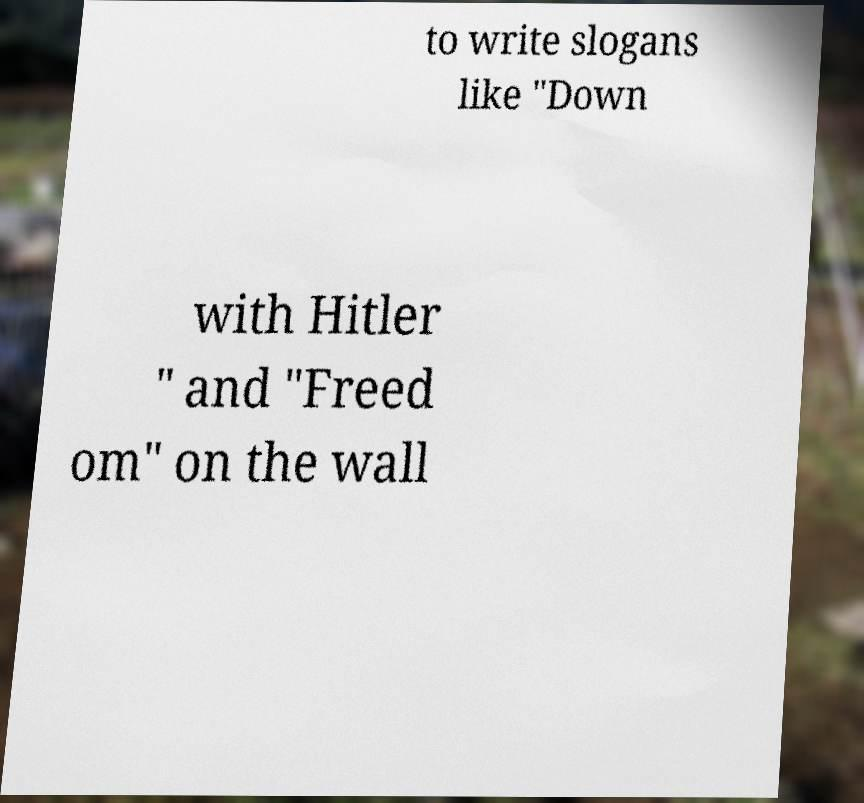Could you assist in decoding the text presented in this image and type it out clearly? to write slogans like "Down with Hitler " and "Freed om" on the wall 